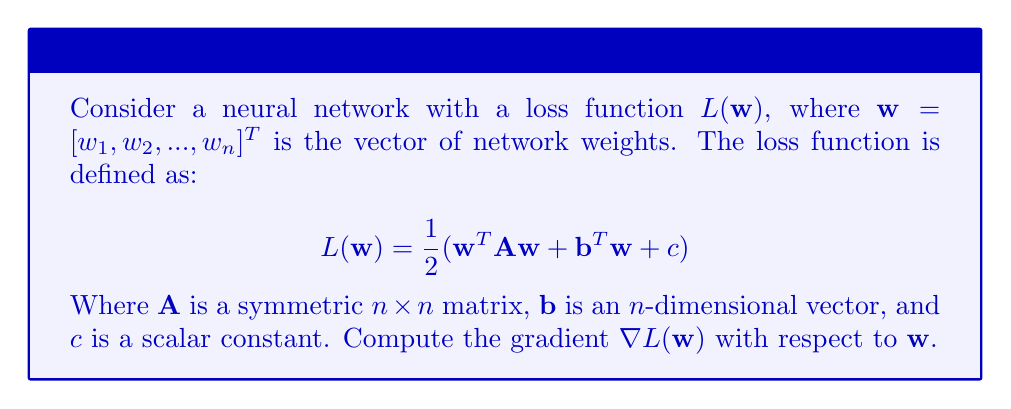What is the answer to this math problem? To compute the gradient $\nabla L(\mathbf{w})$, we need to find the partial derivatives of $L(\mathbf{w})$ with respect to each component of $\mathbf{w}$. Let's approach this step-by-step:

1) First, let's expand the loss function:
   $$L(\mathbf{w}) = \frac{1}{2}(\mathbf{w}^T\mathbf{A}\mathbf{w} + \mathbf{b}^T\mathbf{w} + c)$$

2) The gradient $\nabla L(\mathbf{w})$ is a vector of partial derivatives:
   $$\nabla L(\mathbf{w}) = \left[\frac{\partial L}{\partial w_1}, \frac{\partial L}{\partial w_2}, ..., \frac{\partial L}{\partial w_n}\right]^T$$

3) Let's consider each term in the loss function separately:

   a) For $\mathbf{w}^T\mathbf{A}\mathbf{w}$:
      The gradient of this quadratic form is $\mathbf{A}\mathbf{w} + \mathbf{A}^T\mathbf{w}$. Since $\mathbf{A}$ is symmetric, $\mathbf{A} = \mathbf{A}^T$, so this simplifies to $2\mathbf{A}\mathbf{w}$.

   b) For $\mathbf{b}^T\mathbf{w}$:
      The gradient of this linear term is simply $\mathbf{b}$.

   c) The constant term $c$ disappears in the derivative.

4) Combining these results and accounting for the $\frac{1}{2}$ factor:
   $$\nabla L(\mathbf{w}) = \frac{1}{2}(2\mathbf{A}\mathbf{w} + \mathbf{b})$$

5) Simplifying:
   $$\nabla L(\mathbf{w}) = \mathbf{A}\mathbf{w} + \frac{1}{2}\mathbf{b}$$

This is the gradient of the loss function with respect to the weights $\mathbf{w}$.
Answer: $\nabla L(\mathbf{w}) = \mathbf{A}\mathbf{w} + \frac{1}{2}\mathbf{b}$ 